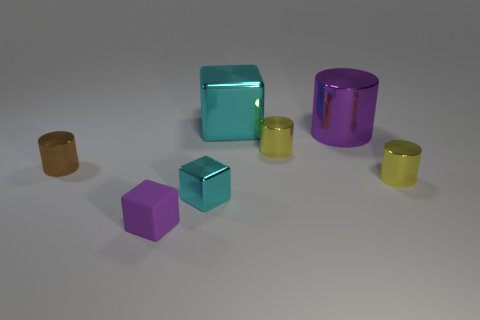Subtract all red cylinders. Subtract all blue cubes. How many cylinders are left? 4 Add 1 small brown spheres. How many objects exist? 8 Subtract all blocks. How many objects are left? 4 Add 7 tiny yellow things. How many tiny yellow things are left? 9 Add 6 purple shiny cylinders. How many purple shiny cylinders exist? 7 Subtract 2 yellow cylinders. How many objects are left? 5 Subtract all tiny cylinders. Subtract all yellow metallic things. How many objects are left? 2 